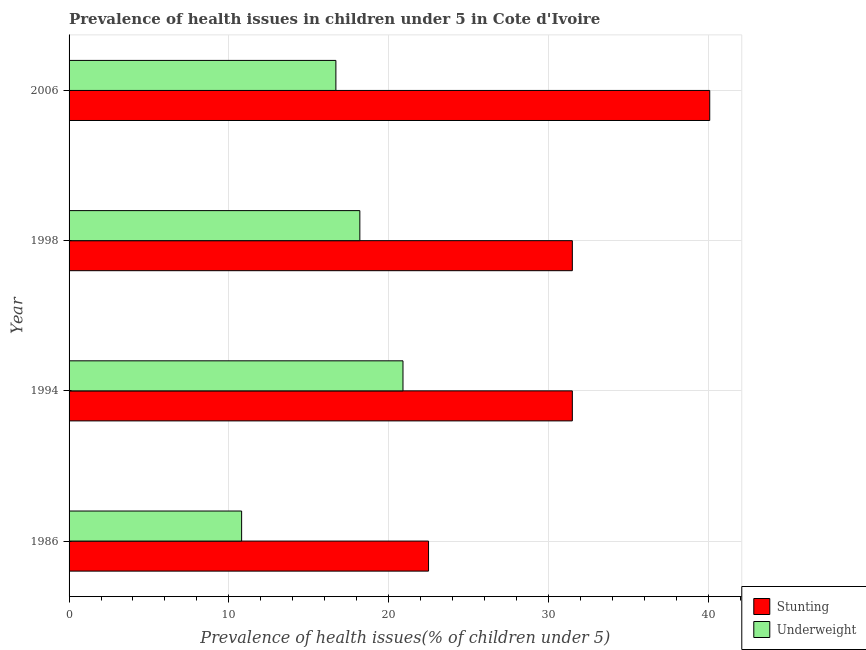How many different coloured bars are there?
Your answer should be compact. 2. How many groups of bars are there?
Ensure brevity in your answer.  4. How many bars are there on the 3rd tick from the top?
Give a very brief answer. 2. What is the label of the 1st group of bars from the top?
Offer a terse response. 2006. What is the percentage of underweight children in 1994?
Provide a short and direct response. 20.9. Across all years, what is the maximum percentage of underweight children?
Your answer should be very brief. 20.9. Across all years, what is the minimum percentage of stunted children?
Provide a succinct answer. 22.5. What is the total percentage of stunted children in the graph?
Your response must be concise. 125.6. What is the difference between the percentage of stunted children in 1986 and that in 1998?
Your answer should be very brief. -9. What is the difference between the percentage of stunted children in 1998 and the percentage of underweight children in 2006?
Keep it short and to the point. 14.8. What is the average percentage of underweight children per year?
Offer a very short reply. 16.65. In how many years, is the percentage of underweight children greater than 10 %?
Your answer should be compact. 4. What is the ratio of the percentage of stunted children in 1998 to that in 2006?
Your response must be concise. 0.79. What is the difference between the highest and the lowest percentage of stunted children?
Ensure brevity in your answer.  17.6. Is the sum of the percentage of stunted children in 1986 and 1998 greater than the maximum percentage of underweight children across all years?
Your answer should be very brief. Yes. What does the 2nd bar from the top in 1994 represents?
Your response must be concise. Stunting. What does the 2nd bar from the bottom in 1994 represents?
Ensure brevity in your answer.  Underweight. Are all the bars in the graph horizontal?
Your answer should be compact. Yes. How many years are there in the graph?
Your answer should be compact. 4. What is the difference between two consecutive major ticks on the X-axis?
Provide a succinct answer. 10. Are the values on the major ticks of X-axis written in scientific E-notation?
Offer a very short reply. No. Does the graph contain grids?
Give a very brief answer. Yes. What is the title of the graph?
Make the answer very short. Prevalence of health issues in children under 5 in Cote d'Ivoire. Does "Research and Development" appear as one of the legend labels in the graph?
Provide a succinct answer. No. What is the label or title of the X-axis?
Give a very brief answer. Prevalence of health issues(% of children under 5). What is the label or title of the Y-axis?
Your answer should be compact. Year. What is the Prevalence of health issues(% of children under 5) of Stunting in 1986?
Your answer should be compact. 22.5. What is the Prevalence of health issues(% of children under 5) of Underweight in 1986?
Make the answer very short. 10.8. What is the Prevalence of health issues(% of children under 5) in Stunting in 1994?
Keep it short and to the point. 31.5. What is the Prevalence of health issues(% of children under 5) of Underweight in 1994?
Offer a terse response. 20.9. What is the Prevalence of health issues(% of children under 5) of Stunting in 1998?
Provide a succinct answer. 31.5. What is the Prevalence of health issues(% of children under 5) in Underweight in 1998?
Your response must be concise. 18.2. What is the Prevalence of health issues(% of children under 5) in Stunting in 2006?
Give a very brief answer. 40.1. What is the Prevalence of health issues(% of children under 5) of Underweight in 2006?
Your answer should be compact. 16.7. Across all years, what is the maximum Prevalence of health issues(% of children under 5) in Stunting?
Offer a terse response. 40.1. Across all years, what is the maximum Prevalence of health issues(% of children under 5) of Underweight?
Provide a succinct answer. 20.9. Across all years, what is the minimum Prevalence of health issues(% of children under 5) in Underweight?
Your answer should be compact. 10.8. What is the total Prevalence of health issues(% of children under 5) in Stunting in the graph?
Offer a very short reply. 125.6. What is the total Prevalence of health issues(% of children under 5) of Underweight in the graph?
Provide a succinct answer. 66.6. What is the difference between the Prevalence of health issues(% of children under 5) in Underweight in 1986 and that in 1994?
Ensure brevity in your answer.  -10.1. What is the difference between the Prevalence of health issues(% of children under 5) of Underweight in 1986 and that in 1998?
Your answer should be compact. -7.4. What is the difference between the Prevalence of health issues(% of children under 5) in Stunting in 1986 and that in 2006?
Your response must be concise. -17.6. What is the difference between the Prevalence of health issues(% of children under 5) in Underweight in 1994 and that in 1998?
Provide a succinct answer. 2.7. What is the difference between the Prevalence of health issues(% of children under 5) of Underweight in 1994 and that in 2006?
Offer a very short reply. 4.2. What is the difference between the Prevalence of health issues(% of children under 5) in Stunting in 1998 and that in 2006?
Keep it short and to the point. -8.6. What is the difference between the Prevalence of health issues(% of children under 5) of Stunting in 1986 and the Prevalence of health issues(% of children under 5) of Underweight in 2006?
Make the answer very short. 5.8. What is the difference between the Prevalence of health issues(% of children under 5) in Stunting in 1998 and the Prevalence of health issues(% of children under 5) in Underweight in 2006?
Offer a very short reply. 14.8. What is the average Prevalence of health issues(% of children under 5) of Stunting per year?
Keep it short and to the point. 31.4. What is the average Prevalence of health issues(% of children under 5) of Underweight per year?
Offer a terse response. 16.65. In the year 1986, what is the difference between the Prevalence of health issues(% of children under 5) in Stunting and Prevalence of health issues(% of children under 5) in Underweight?
Make the answer very short. 11.7. In the year 1998, what is the difference between the Prevalence of health issues(% of children under 5) in Stunting and Prevalence of health issues(% of children under 5) in Underweight?
Your response must be concise. 13.3. In the year 2006, what is the difference between the Prevalence of health issues(% of children under 5) of Stunting and Prevalence of health issues(% of children under 5) of Underweight?
Ensure brevity in your answer.  23.4. What is the ratio of the Prevalence of health issues(% of children under 5) of Underweight in 1986 to that in 1994?
Keep it short and to the point. 0.52. What is the ratio of the Prevalence of health issues(% of children under 5) of Underweight in 1986 to that in 1998?
Give a very brief answer. 0.59. What is the ratio of the Prevalence of health issues(% of children under 5) of Stunting in 1986 to that in 2006?
Provide a short and direct response. 0.56. What is the ratio of the Prevalence of health issues(% of children under 5) of Underweight in 1986 to that in 2006?
Offer a very short reply. 0.65. What is the ratio of the Prevalence of health issues(% of children under 5) in Stunting in 1994 to that in 1998?
Offer a very short reply. 1. What is the ratio of the Prevalence of health issues(% of children under 5) of Underweight in 1994 to that in 1998?
Keep it short and to the point. 1.15. What is the ratio of the Prevalence of health issues(% of children under 5) of Stunting in 1994 to that in 2006?
Ensure brevity in your answer.  0.79. What is the ratio of the Prevalence of health issues(% of children under 5) of Underweight in 1994 to that in 2006?
Give a very brief answer. 1.25. What is the ratio of the Prevalence of health issues(% of children under 5) of Stunting in 1998 to that in 2006?
Your answer should be compact. 0.79. What is the ratio of the Prevalence of health issues(% of children under 5) in Underweight in 1998 to that in 2006?
Offer a very short reply. 1.09. What is the difference between the highest and the second highest Prevalence of health issues(% of children under 5) of Stunting?
Keep it short and to the point. 8.6. What is the difference between the highest and the lowest Prevalence of health issues(% of children under 5) of Stunting?
Offer a very short reply. 17.6. 